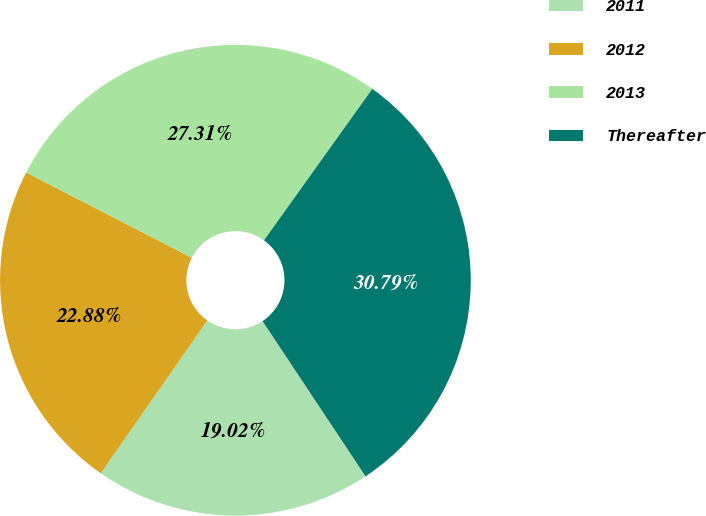Convert chart. <chart><loc_0><loc_0><loc_500><loc_500><pie_chart><fcel>2011<fcel>2012<fcel>2013<fcel>Thereafter<nl><fcel>19.02%<fcel>22.88%<fcel>27.31%<fcel>30.79%<nl></chart> 